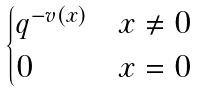Convert formula to latex. <formula><loc_0><loc_0><loc_500><loc_500>\begin{cases} q ^ { - v ( x ) } & x \neq 0 \\ 0 & x = 0 \end{cases}</formula> 